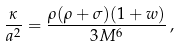Convert formula to latex. <formula><loc_0><loc_0><loc_500><loc_500>\frac { \kappa } { a ^ { 2 } } = \frac { \rho ( \rho + \sigma ) ( 1 + w ) } { 3 M ^ { 6 } } \, ,</formula> 